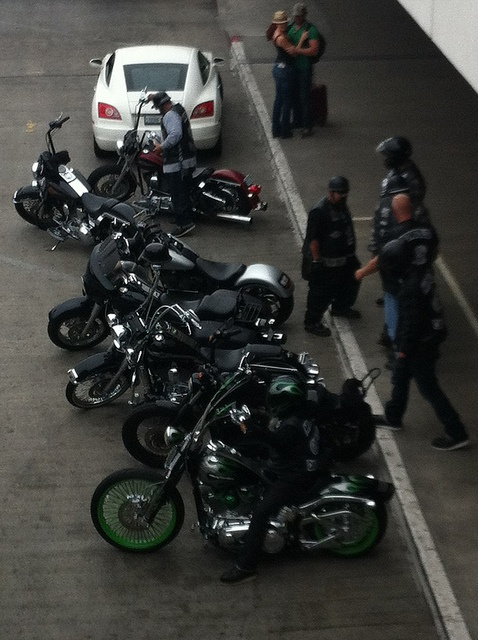Describe the objects in this image and their specific colors. I can see motorcycle in gray, black, darkgreen, and darkgray tones, motorcycle in gray, black, and darkgray tones, motorcycle in gray, black, darkgray, and white tones, car in gray, white, darkgray, and black tones, and motorcycle in gray, black, and purple tones in this image. 